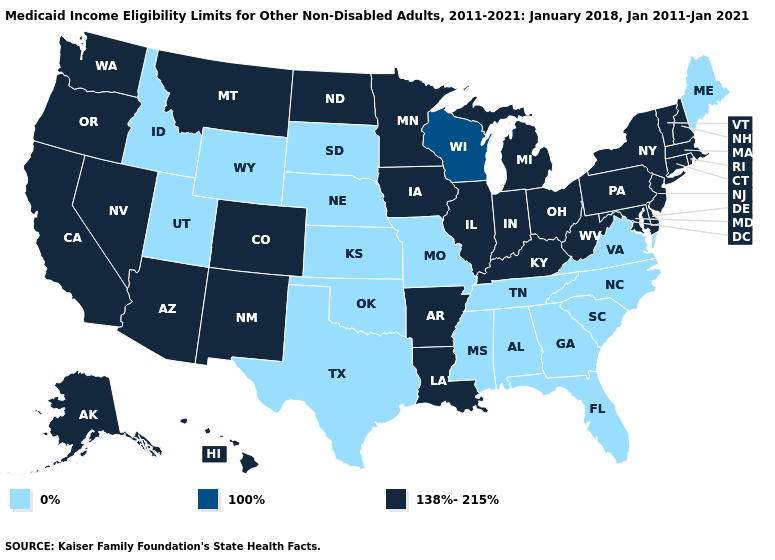Name the states that have a value in the range 100%?
Short answer required. Wisconsin. Name the states that have a value in the range 100%?
Give a very brief answer. Wisconsin. What is the value of Mississippi?
Short answer required. 0%. Does Missouri have a lower value than Maine?
Answer briefly. No. What is the highest value in states that border Kansas?
Concise answer only. 138%-215%. Does Nevada have a lower value than Missouri?
Answer briefly. No. Which states have the highest value in the USA?
Give a very brief answer. Alaska, Arizona, Arkansas, California, Colorado, Connecticut, Delaware, Hawaii, Illinois, Indiana, Iowa, Kentucky, Louisiana, Maryland, Massachusetts, Michigan, Minnesota, Montana, Nevada, New Hampshire, New Jersey, New Mexico, New York, North Dakota, Ohio, Oregon, Pennsylvania, Rhode Island, Vermont, Washington, West Virginia. Which states have the lowest value in the USA?
Give a very brief answer. Alabama, Florida, Georgia, Idaho, Kansas, Maine, Mississippi, Missouri, Nebraska, North Carolina, Oklahoma, South Carolina, South Dakota, Tennessee, Texas, Utah, Virginia, Wyoming. Does South Dakota have the highest value in the MidWest?
Short answer required. No. How many symbols are there in the legend?
Keep it brief. 3. What is the lowest value in states that border Arkansas?
Quick response, please. 0%. What is the value of Alabama?
Write a very short answer. 0%. What is the value of Maine?
Concise answer only. 0%. Does Colorado have the lowest value in the West?
Give a very brief answer. No. Name the states that have a value in the range 100%?
Keep it brief. Wisconsin. 